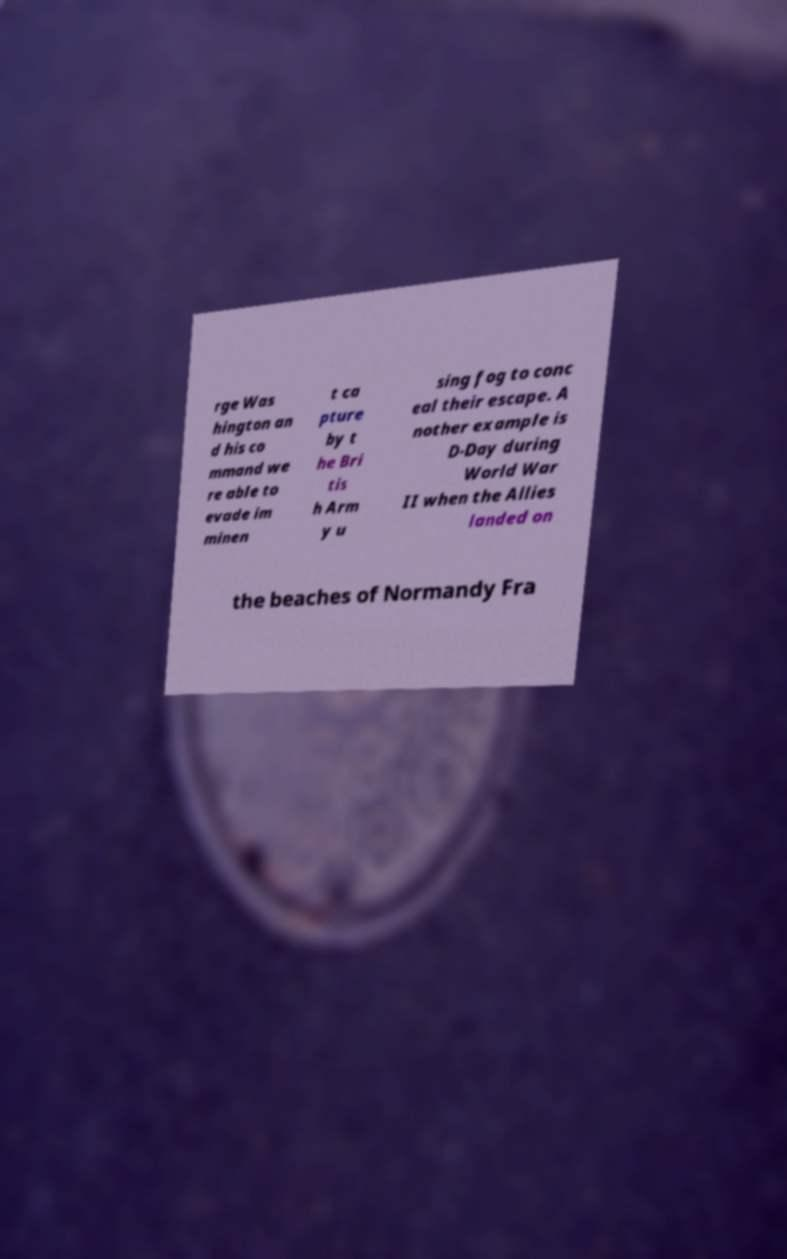Can you accurately transcribe the text from the provided image for me? rge Was hington an d his co mmand we re able to evade im minen t ca pture by t he Bri tis h Arm y u sing fog to conc eal their escape. A nother example is D-Day during World War II when the Allies landed on the beaches of Normandy Fra 